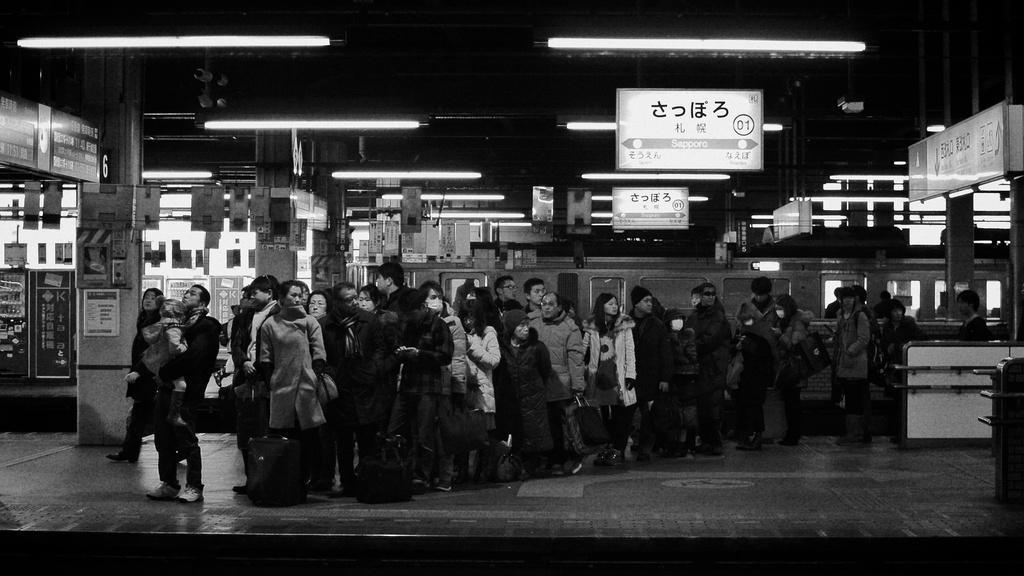Could you give a brief overview of what you see in this image? In this picture we can see group of people, behind them we can see few lights, hoardings and a train, it is a black and white photography. 